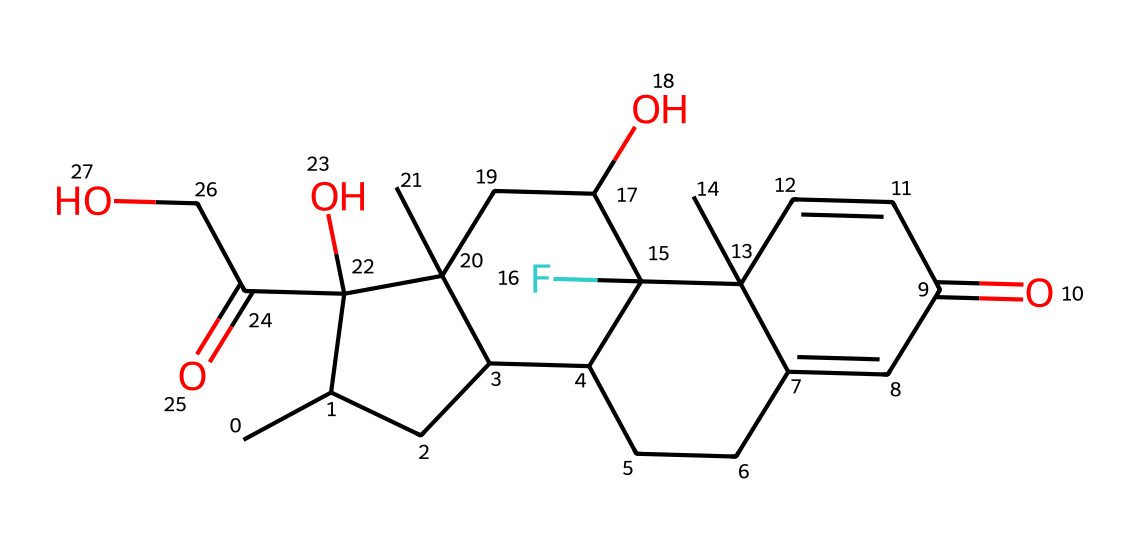What is the primary functional group present in dexamethasone? In the SMILES representation, the presence of a carbonyl group (C=O) suggests it has ketone characteristics. An alcohol group (O) is also present. Thus, it primarily features ketones and hydroxyl groups as functional groups.
Answer: ketone and hydroxyl How many rings are present in the structure? By analyzing the SMILES structure, it can be noted that there are four cyclic components formed, indicated by the 'C' and numeric identifiers which denote ring closures. This indicates the presence of four rings in the structure.
Answer: four What is the total number of oxygen atoms in dexamethasone? The SMILES structure reveals the presence of oxygen atoms by identifying 'O' in the chain. Counting these gives us a total of five oxygen atoms present in the dexamethasone molecule.
Answer: five What is the molecular formula of dexamethasone? The molecular formula can be deduced by counting the number of each type of atom in the SMILES representation. In this case, the count results in the formula C22H29F2O5.
Answer: C22H29F2O5 What type of molecule is dexamethasone classified as? The structure features multiple steroid rings and functional groups characteristic of glucocorticoids, indicating its classification. Therefore, dexamethasone is classified specifically as a corticosteroid.
Answer: corticosteroid 